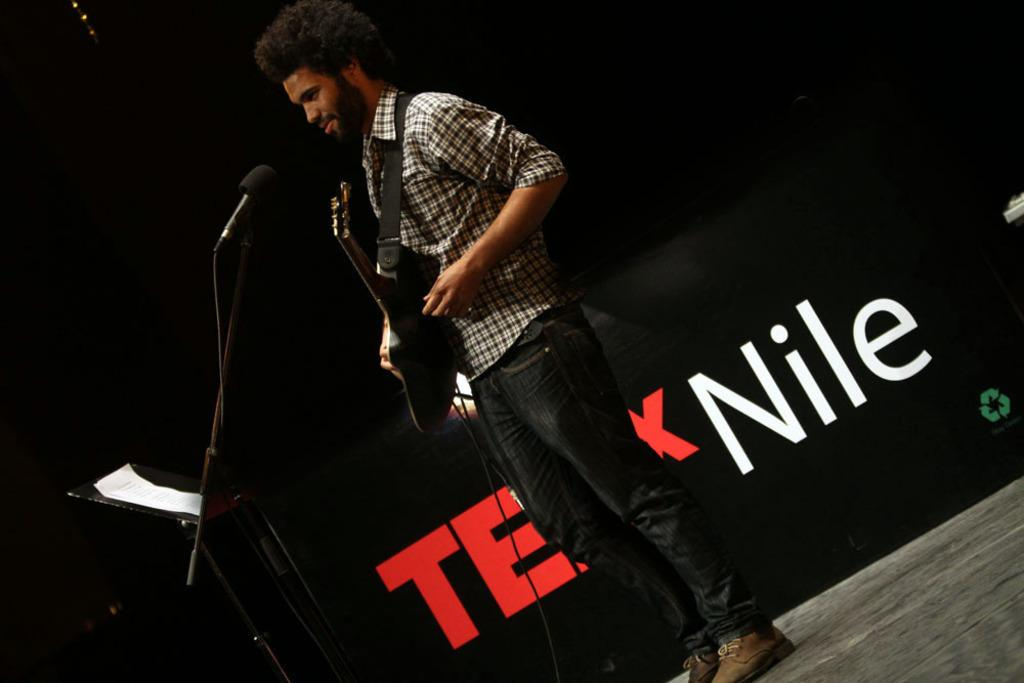What is the person in the image doing? The person is standing in the image and carrying a guitar. What object is present near the person? There is a microphone on a stand in the image. What is on the microphone stand? There is a paper on the stand. What can be seen in the background of the image? There is a banner visible in the background. How many children are playing with credit cards in the image? There are no children or credit cards present in the image. 